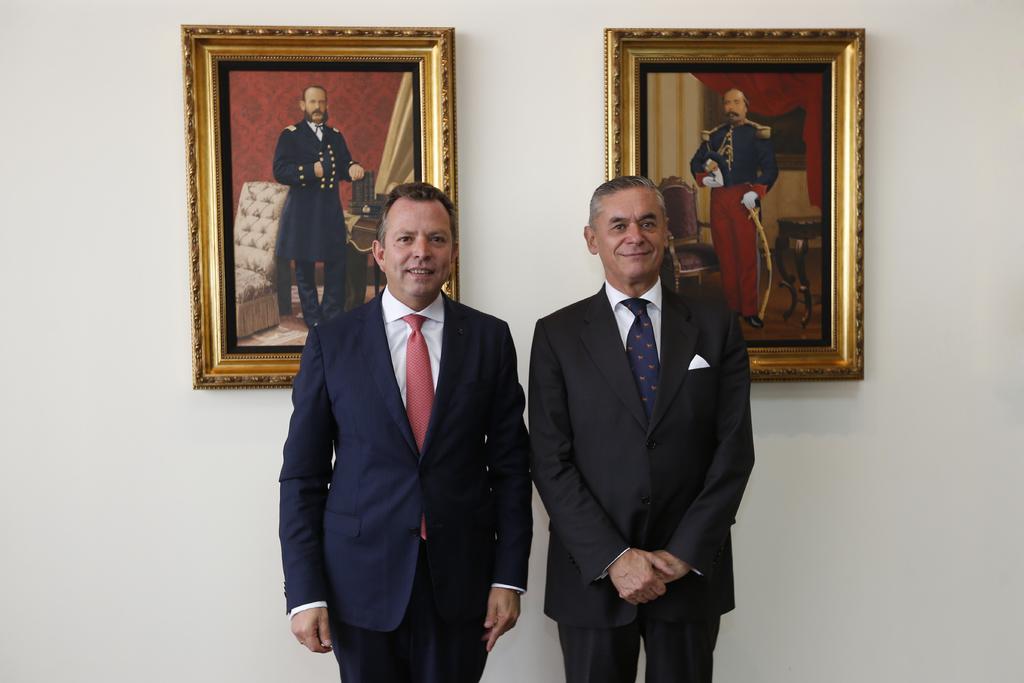In one or two sentences, can you explain what this image depicts? In this picture I can see two persons standing and smiling, and in the background there are frames attached to the wall. 